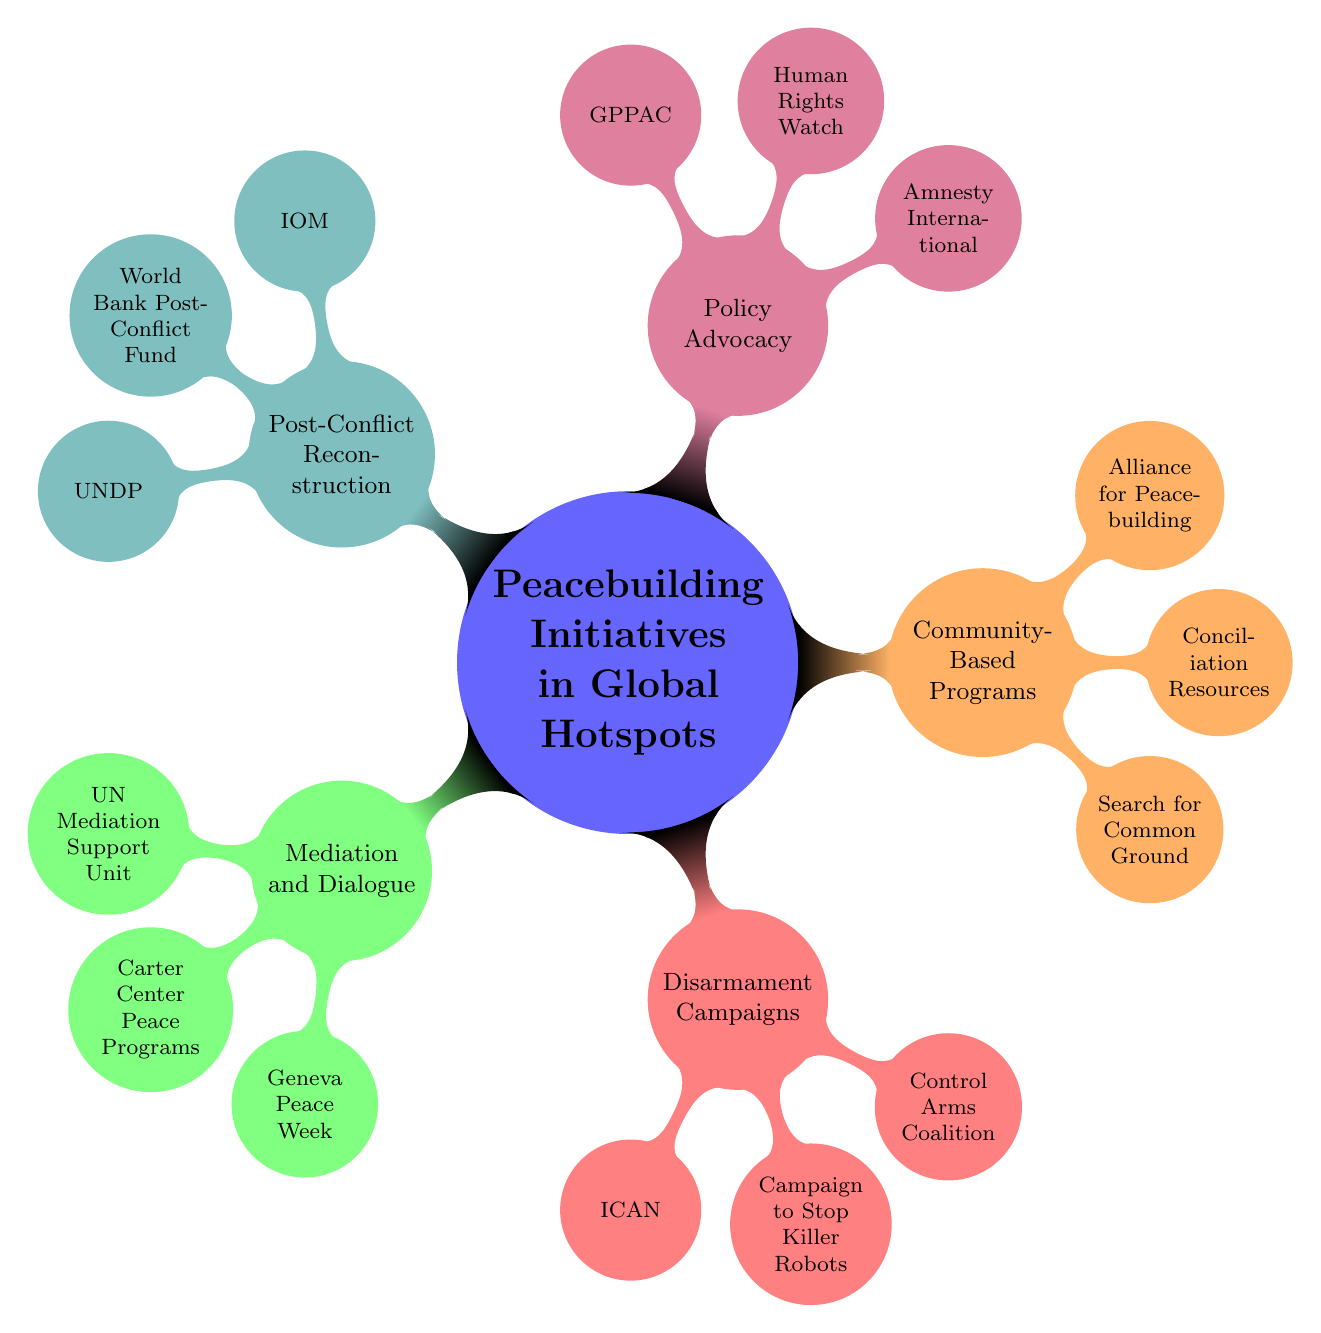What are the main categories of peacebuilding initiatives? The main categories are listed as five main nodes branching from the central theme. They are: Mediation and Dialogue, Disarmament Campaigns, Community-Based Programs, Policy Advocacy, and Post-Conflict Reconstruction.
Answer: Mediation and Dialogue, Disarmament Campaigns, Community-Based Programs, Policy Advocacy, Post-Conflict Reconstruction How many initiatives are listed under "Disarmament Campaigns"? The "Disarmament Campaigns" node has three child nodes linked to it: ICAN, Campaign to Stop Killer Robots, and Control Arms Coalition. Counting these gives a total of three initiatives.
Answer: 3 Which organization is associated with "Policy Advocacy"? The "Policy Advocacy" node has three organizations listed as its child nodes: Amnesty International, Human Rights Watch, and Global Partnership for the Prevention of Armed Conflict (GPPAC). Any of these could be mentioned as associated organizations.
Answer: Amnesty International What type of programs does "Search for Common Ground" represent? The "Search for Common Ground" node is located under the "Community-Based Programs" category. This indicates that it represents initiatives that work at the community level to promote peace.
Answer: Community-Based Programs Which initiative focuses specifically on the abolition of nuclear weapons? The "International Campaign to Abolish Nuclear Weapons (ICAN)" is explicitly mentioned as part of the "Disarmament Campaigns," indicating its focus on the abolition of nuclear weapons.
Answer: International Campaign to Abolish Nuclear Weapons (ICAN) How many nodes are there in total under the "Mediation and Dialogue" category? The "Mediation and Dialogue" category has three child nodes: UN Mediation Support Unit, Carter Center Peace Programs, and Geneva Peace Week, making a total of three nodes.
Answer: 3 Which two initiatives focus on international aid post-conflict? The initiatives under "Post-Conflict Reconstruction" include the International Organization for Migration (IOM) and the World Bank Post-Conflict Fund. Both are focused on international aid in post-conflict situations.
Answer: International Organization for Migration (IOM), World Bank Post-Conflict Fund What is the primary purpose of "Geneva Peace Week"? Since "Geneva Peace Week" is listed under the "Mediation and Dialogue" category, its primary purpose relates to facilitating dialogue and mediation efforts in peacebuilding contexts.
Answer: Dialogue and mediation efforts 